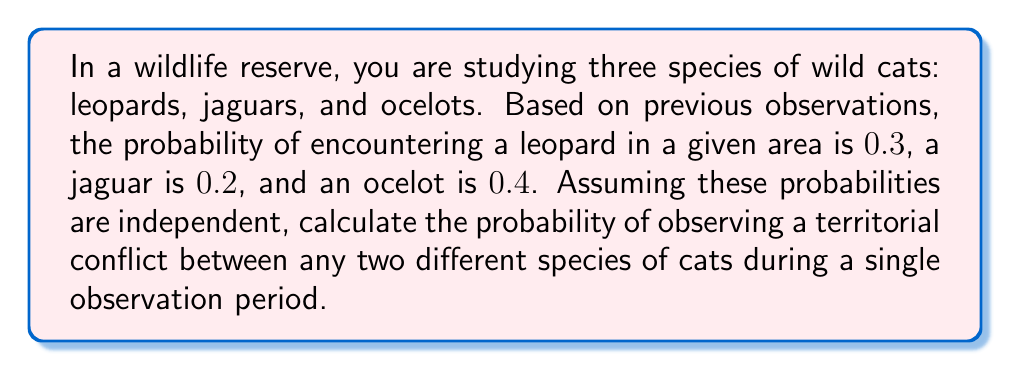Solve this math problem. To solve this problem, we need to follow these steps:

1. Identify the possible combinations of two different species:
   - Leopard and Jaguar
   - Leopard and Ocelot
   - Jaguar and Ocelot

2. Calculate the probability of each combination:
   
   For Leopard and Jaguar:
   $$P(\text{Leopard and Jaguar}) = P(\text{Leopard}) \times P(\text{Jaguar}) = 0.3 \times 0.2 = 0.06$$
   
   For Leopard and Ocelot:
   $$P(\text{Leopard and Ocelot}) = P(\text{Leopard}) \times P(\text{Ocelot}) = 0.3 \times 0.4 = 0.12$$
   
   For Jaguar and Ocelot:
   $$P(\text{Jaguar and Ocelot}) = P(\text{Jaguar}) \times P(\text{Ocelot}) = 0.2 \times 0.4 = 0.08$$

3. Sum up the probabilities of all possible combinations:
   $$P(\text{Any two different species}) = P(\text{Leopard and Jaguar}) + P(\text{Leopard and Ocelot}) + P(\text{Jaguar and Ocelot})$$
   $$P(\text{Any two different species}) = 0.06 + 0.12 + 0.08 = 0.26$$

Therefore, the probability of observing a territorial conflict between any two different species of cats during a single observation period is 0.26 or 26%.
Answer: 0.26 or 26% 